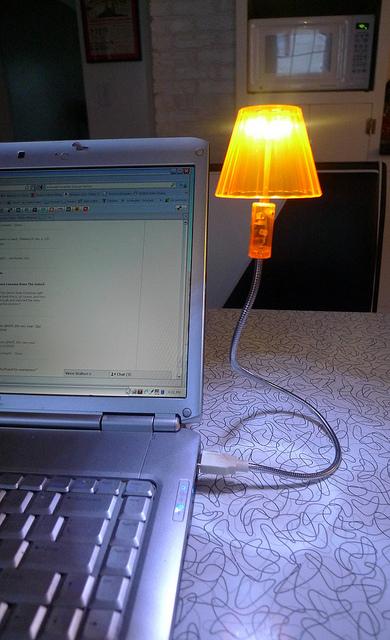Is this an Apple product?
Write a very short answer. No. What color is the light?
Keep it brief. Yellow. Is the light plugged into the wall?
Keep it brief. No. What color is the laptop?
Keep it brief. Silver. 